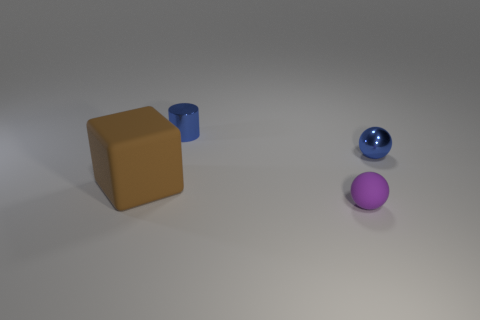Subtract all gray cylinders. Subtract all gray cubes. How many cylinders are left? 1 Add 1 big yellow matte cylinders. How many objects exist? 5 Subtract all cylinders. How many objects are left? 3 Add 1 large rubber things. How many large rubber things exist? 2 Subtract 1 purple balls. How many objects are left? 3 Subtract all purple metal balls. Subtract all tiny spheres. How many objects are left? 2 Add 1 large matte blocks. How many large matte blocks are left? 2 